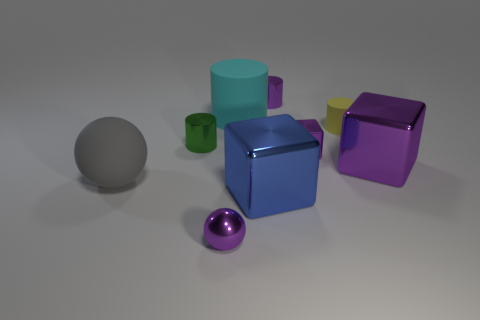Subtract all gray cylinders. Subtract all red blocks. How many cylinders are left? 4 Add 1 purple metallic blocks. How many objects exist? 10 Subtract all cubes. How many objects are left? 6 Subtract 0 cyan cubes. How many objects are left? 9 Subtract all large brown things. Subtract all tiny matte cylinders. How many objects are left? 8 Add 5 small yellow matte objects. How many small yellow matte objects are left? 6 Add 3 purple objects. How many purple objects exist? 7 